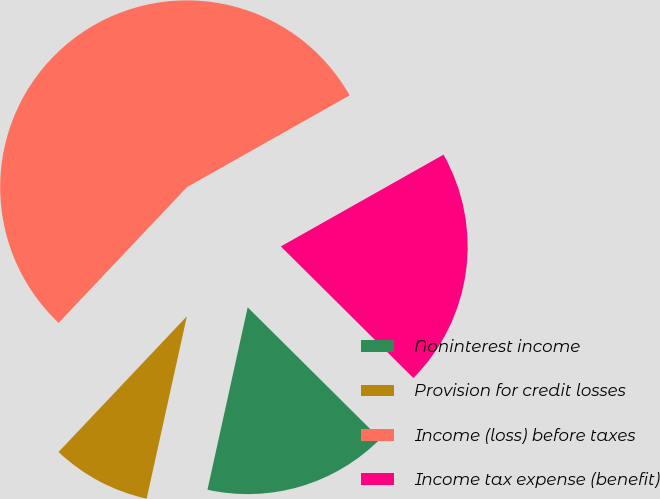Convert chart. <chart><loc_0><loc_0><loc_500><loc_500><pie_chart><fcel>Noninterest income<fcel>Provision for credit losses<fcel>Income (loss) before taxes<fcel>Income tax expense (benefit)<nl><fcel>16.01%<fcel>8.6%<fcel>54.77%<fcel>20.62%<nl></chart> 